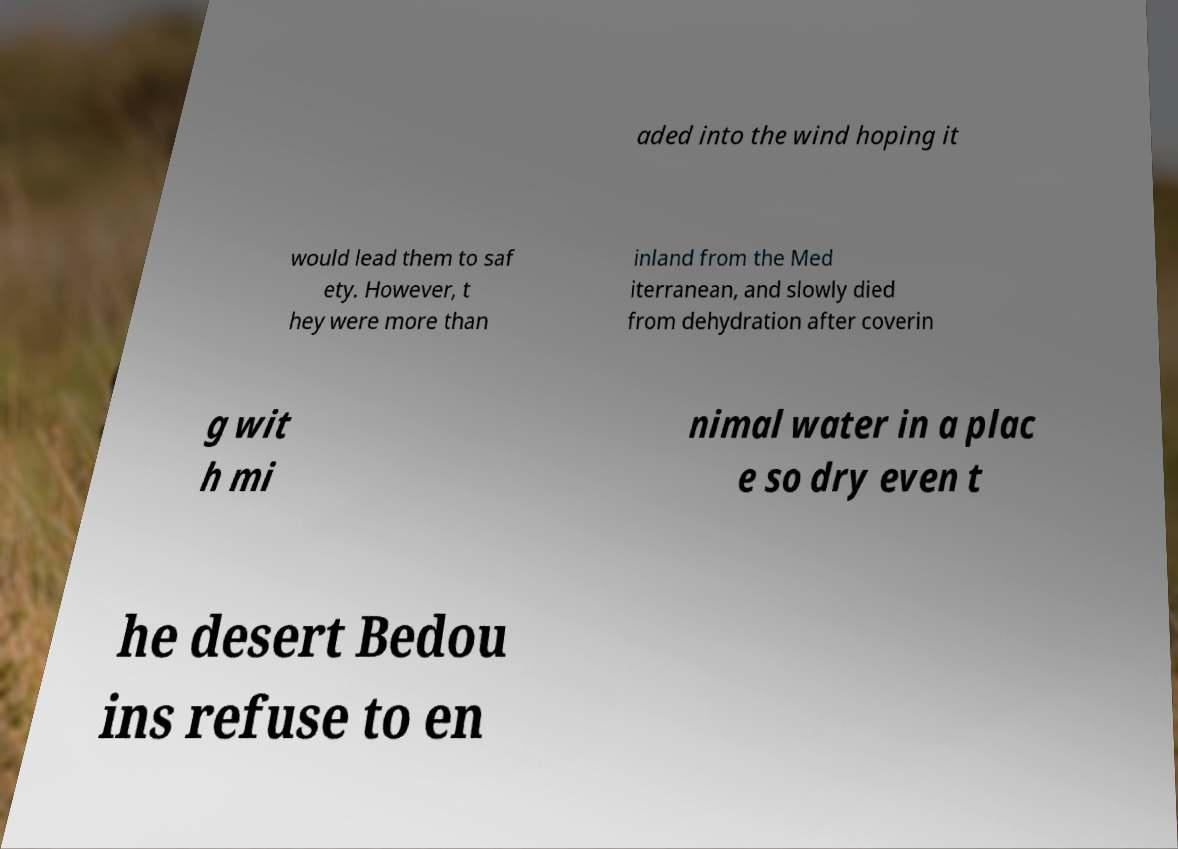Can you read and provide the text displayed in the image?This photo seems to have some interesting text. Can you extract and type it out for me? aded into the wind hoping it would lead them to saf ety. However, t hey were more than inland from the Med iterranean, and slowly died from dehydration after coverin g wit h mi nimal water in a plac e so dry even t he desert Bedou ins refuse to en 